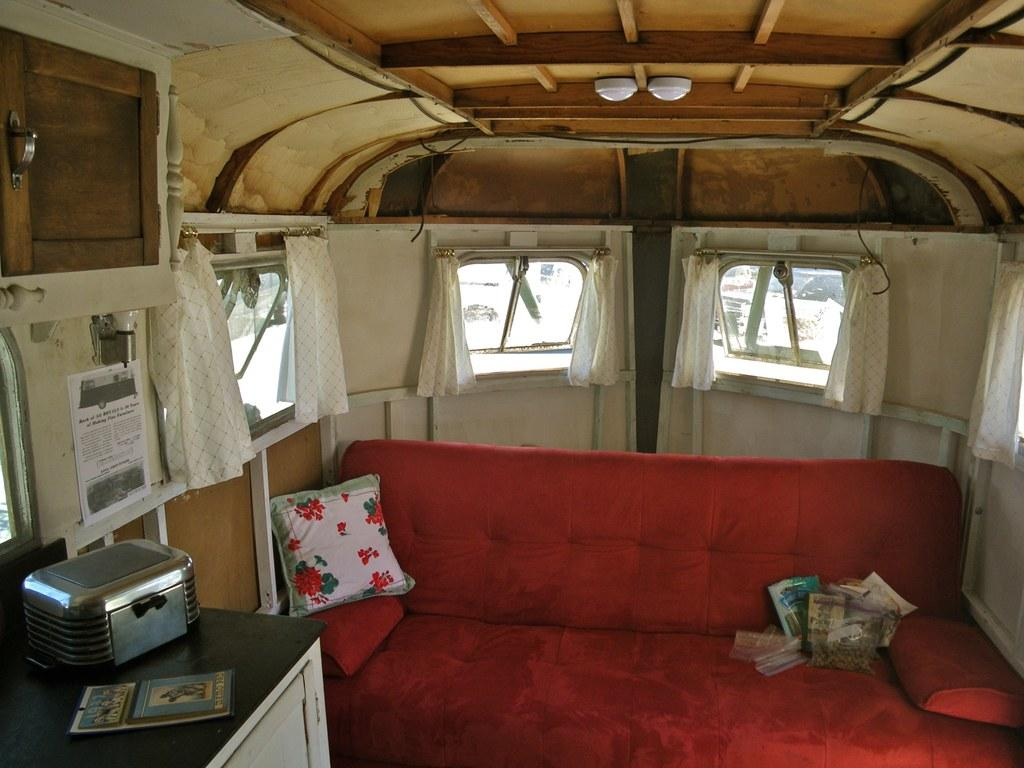What type of vehicle is shown in the image? The image shows the inside view of a vehicle. What furniture is present in the vehicle? There is a sofa in the vehicle. What is placed on the sofa? There is a pillow on the sofa. What storage feature is present in the vehicle? There is a cupboard in the vehicle. What allows natural light to enter the vehicle? There are windows in the vehicle. What is used to cover the windows for privacy or light control? There is a curtain associated with the windows. What type of beef is being cooked on the stove in the image? There is no stove or beef present in the image; it shows the inside view of a vehicle with a sofa, pillow, cupboard, windows, and curtain. 